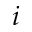Convert formula to latex. <formula><loc_0><loc_0><loc_500><loc_500>i</formula> 